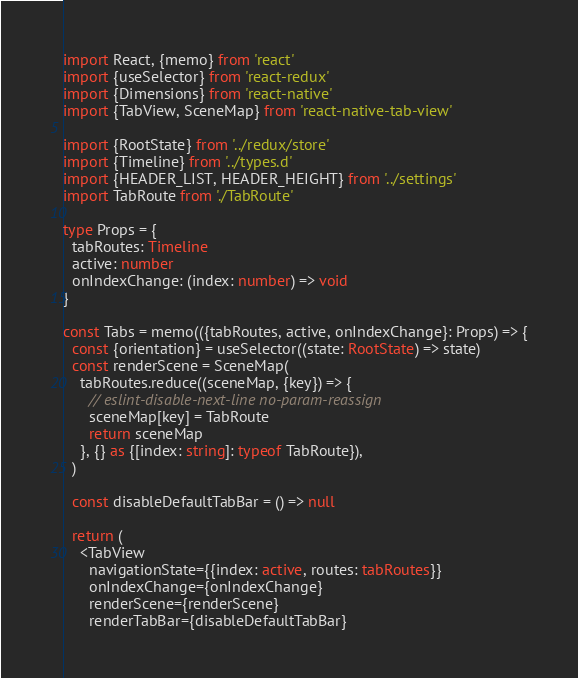<code> <loc_0><loc_0><loc_500><loc_500><_TypeScript_>import React, {memo} from 'react'
import {useSelector} from 'react-redux'
import {Dimensions} from 'react-native'
import {TabView, SceneMap} from 'react-native-tab-view'

import {RootState} from '../redux/store'
import {Timeline} from '../types.d'
import {HEADER_LIST, HEADER_HEIGHT} from '../settings'
import TabRoute from './TabRoute'

type Props = {
  tabRoutes: Timeline
  active: number
  onIndexChange: (index: number) => void
}

const Tabs = memo(({tabRoutes, active, onIndexChange}: Props) => {
  const {orientation} = useSelector((state: RootState) => state)
  const renderScene = SceneMap(
    tabRoutes.reduce((sceneMap, {key}) => {
      // eslint-disable-next-line no-param-reassign
      sceneMap[key] = TabRoute
      return sceneMap
    }, {} as {[index: string]: typeof TabRoute}),
  )

  const disableDefaultTabBar = () => null

  return (
    <TabView
      navigationState={{index: active, routes: tabRoutes}}
      onIndexChange={onIndexChange}
      renderScene={renderScene}
      renderTabBar={disableDefaultTabBar}</code> 